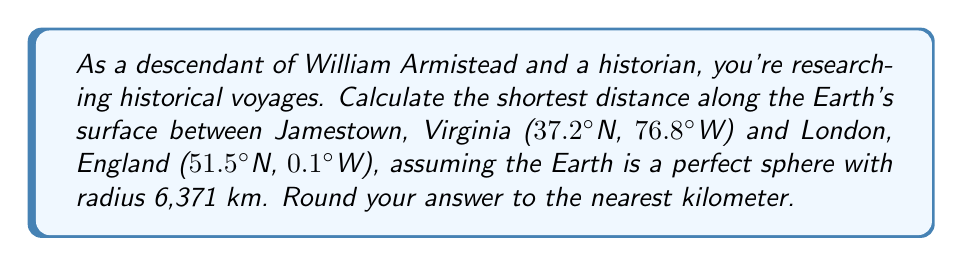Show me your answer to this math problem. To solve this problem, we'll use the great-circle distance formula:

$$d = R \cdot \arccos[\sin(\phi_1)\sin(\phi_2) + \cos(\phi_1)\cos(\phi_2)\cos(\Delta\lambda)]$$

Where:
- $d$ is the distance
- $R$ is the Earth's radius (6,371 km)
- $\phi_1, \phi_2$ are the latitudes of the two points in radians
- $\Delta\lambda$ is the absolute difference in longitude in radians

Step 1: Convert latitudes and longitudes to radians
$\phi_1 = 37.2° \cdot \frac{\pi}{180} = 0.6495$ rad
$\phi_2 = 51.5° \cdot \frac{\pi}{180} = 0.8987$ rad
$\lambda_1 = -76.8° \cdot \frac{\pi}{180} = -1.3404$ rad
$\lambda_2 = -0.1° \cdot \frac{\pi}{180} = -0.0017$ rad

Step 2: Calculate $\Delta\lambda$
$\Delta\lambda = |\lambda_1 - \lambda_2| = |-1.3404 - (-0.0017)| = 1.3387$ rad

Step 3: Apply the great-circle distance formula
$$\begin{aligned}
d &= 6371 \cdot \arccos[\sin(0.6495)\sin(0.8987) + \cos(0.6495)\cos(0.8987)\cos(1.3387)] \\
&= 6371 \cdot \arccos[0.5990 + 0.4010 \cdot 0.2392] \\
&= 6371 \cdot \arccos(0.6949) \\
&= 6371 \cdot 0.8039 \\
&= 5121.7 \text{ km}
\end{aligned}$$

Step 4: Round to the nearest kilometer
$5121.7 \text{ km} \approx 5122 \text{ km}$
Answer: 5122 km 